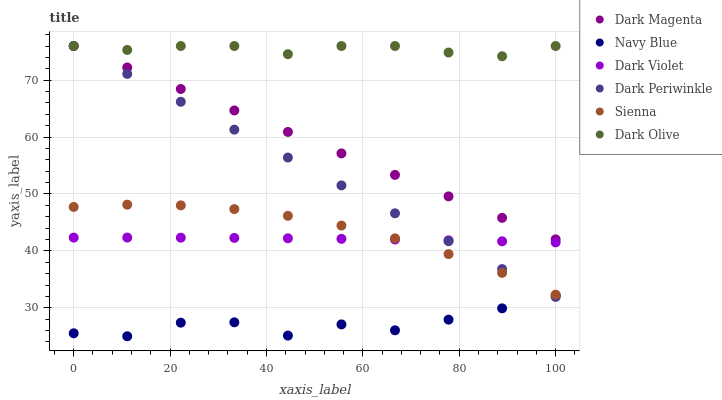Does Navy Blue have the minimum area under the curve?
Answer yes or no. Yes. Does Dark Olive have the maximum area under the curve?
Answer yes or no. Yes. Does Dark Olive have the minimum area under the curve?
Answer yes or no. No. Does Navy Blue have the maximum area under the curve?
Answer yes or no. No. Is Dark Magenta the smoothest?
Answer yes or no. Yes. Is Navy Blue the roughest?
Answer yes or no. Yes. Is Dark Olive the smoothest?
Answer yes or no. No. Is Dark Olive the roughest?
Answer yes or no. No. Does Navy Blue have the lowest value?
Answer yes or no. Yes. Does Dark Olive have the lowest value?
Answer yes or no. No. Does Dark Periwinkle have the highest value?
Answer yes or no. Yes. Does Navy Blue have the highest value?
Answer yes or no. No. Is Dark Violet less than Dark Olive?
Answer yes or no. Yes. Is Dark Magenta greater than Sienna?
Answer yes or no. Yes. Does Dark Periwinkle intersect Dark Violet?
Answer yes or no. Yes. Is Dark Periwinkle less than Dark Violet?
Answer yes or no. No. Is Dark Periwinkle greater than Dark Violet?
Answer yes or no. No. Does Dark Violet intersect Dark Olive?
Answer yes or no. No. 